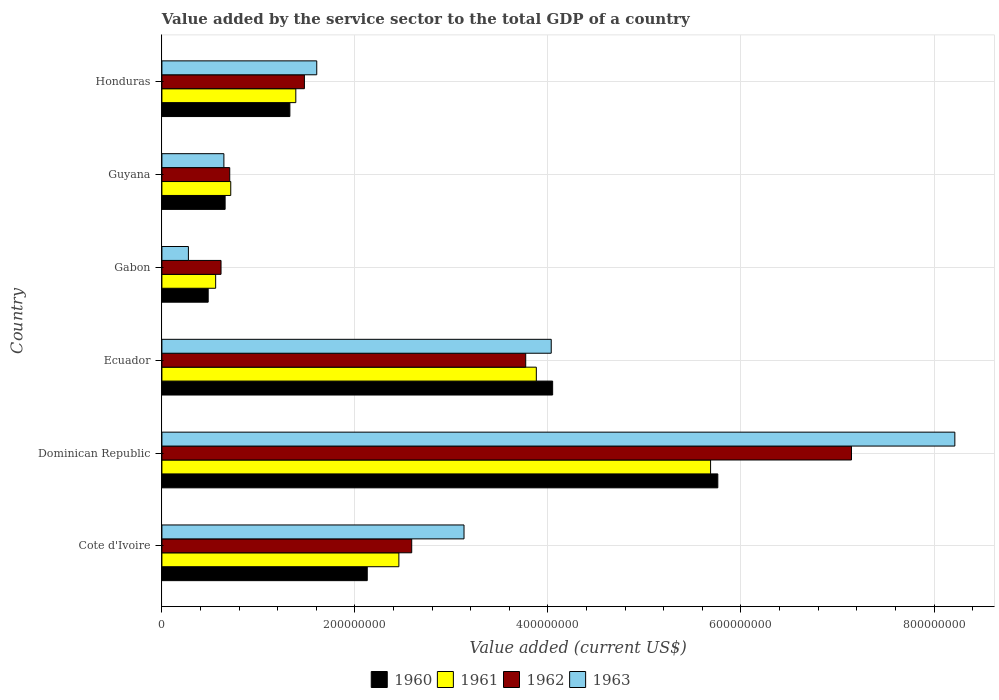How many different coloured bars are there?
Provide a succinct answer. 4. How many bars are there on the 2nd tick from the top?
Keep it short and to the point. 4. How many bars are there on the 2nd tick from the bottom?
Your response must be concise. 4. What is the label of the 3rd group of bars from the top?
Your answer should be compact. Gabon. What is the value added by the service sector to the total GDP in 1961 in Guyana?
Give a very brief answer. 7.13e+07. Across all countries, what is the maximum value added by the service sector to the total GDP in 1962?
Ensure brevity in your answer.  7.14e+08. Across all countries, what is the minimum value added by the service sector to the total GDP in 1961?
Provide a succinct answer. 5.57e+07. In which country was the value added by the service sector to the total GDP in 1962 maximum?
Provide a short and direct response. Dominican Republic. In which country was the value added by the service sector to the total GDP in 1961 minimum?
Your answer should be compact. Gabon. What is the total value added by the service sector to the total GDP in 1963 in the graph?
Your answer should be very brief. 1.79e+09. What is the difference between the value added by the service sector to the total GDP in 1960 in Ecuador and that in Guyana?
Your answer should be very brief. 3.39e+08. What is the difference between the value added by the service sector to the total GDP in 1963 in Guyana and the value added by the service sector to the total GDP in 1961 in Gabon?
Offer a terse response. 8.53e+06. What is the average value added by the service sector to the total GDP in 1960 per country?
Your answer should be very brief. 2.40e+08. What is the difference between the value added by the service sector to the total GDP in 1961 and value added by the service sector to the total GDP in 1963 in Honduras?
Make the answer very short. -2.17e+07. In how many countries, is the value added by the service sector to the total GDP in 1961 greater than 360000000 US$?
Offer a very short reply. 2. What is the ratio of the value added by the service sector to the total GDP in 1961 in Dominican Republic to that in Ecuador?
Give a very brief answer. 1.47. Is the difference between the value added by the service sector to the total GDP in 1961 in Cote d'Ivoire and Dominican Republic greater than the difference between the value added by the service sector to the total GDP in 1963 in Cote d'Ivoire and Dominican Republic?
Your answer should be very brief. Yes. What is the difference between the highest and the second highest value added by the service sector to the total GDP in 1963?
Provide a short and direct response. 4.18e+08. What is the difference between the highest and the lowest value added by the service sector to the total GDP in 1962?
Your answer should be compact. 6.53e+08. In how many countries, is the value added by the service sector to the total GDP in 1961 greater than the average value added by the service sector to the total GDP in 1961 taken over all countries?
Ensure brevity in your answer.  3. What does the 2nd bar from the bottom in Cote d'Ivoire represents?
Give a very brief answer. 1961. Is it the case that in every country, the sum of the value added by the service sector to the total GDP in 1962 and value added by the service sector to the total GDP in 1963 is greater than the value added by the service sector to the total GDP in 1961?
Your answer should be very brief. Yes. How many bars are there?
Offer a terse response. 24. Are all the bars in the graph horizontal?
Give a very brief answer. Yes. Are the values on the major ticks of X-axis written in scientific E-notation?
Keep it short and to the point. No. Does the graph contain any zero values?
Give a very brief answer. No. Does the graph contain grids?
Give a very brief answer. Yes. What is the title of the graph?
Keep it short and to the point. Value added by the service sector to the total GDP of a country. Does "1965" appear as one of the legend labels in the graph?
Make the answer very short. No. What is the label or title of the X-axis?
Provide a succinct answer. Value added (current US$). What is the label or title of the Y-axis?
Provide a short and direct response. Country. What is the Value added (current US$) in 1960 in Cote d'Ivoire?
Your answer should be very brief. 2.13e+08. What is the Value added (current US$) of 1961 in Cote d'Ivoire?
Provide a succinct answer. 2.46e+08. What is the Value added (current US$) of 1962 in Cote d'Ivoire?
Your answer should be very brief. 2.59e+08. What is the Value added (current US$) in 1963 in Cote d'Ivoire?
Provide a short and direct response. 3.13e+08. What is the Value added (current US$) of 1960 in Dominican Republic?
Offer a terse response. 5.76e+08. What is the Value added (current US$) in 1961 in Dominican Republic?
Provide a short and direct response. 5.68e+08. What is the Value added (current US$) in 1962 in Dominican Republic?
Your answer should be compact. 7.14e+08. What is the Value added (current US$) of 1963 in Dominican Republic?
Your response must be concise. 8.22e+08. What is the Value added (current US$) of 1960 in Ecuador?
Give a very brief answer. 4.05e+08. What is the Value added (current US$) in 1961 in Ecuador?
Your response must be concise. 3.88e+08. What is the Value added (current US$) in 1962 in Ecuador?
Give a very brief answer. 3.77e+08. What is the Value added (current US$) of 1963 in Ecuador?
Give a very brief answer. 4.03e+08. What is the Value added (current US$) in 1960 in Gabon?
Your answer should be compact. 4.80e+07. What is the Value added (current US$) in 1961 in Gabon?
Give a very brief answer. 5.57e+07. What is the Value added (current US$) of 1962 in Gabon?
Give a very brief answer. 6.13e+07. What is the Value added (current US$) of 1963 in Gabon?
Ensure brevity in your answer.  2.75e+07. What is the Value added (current US$) in 1960 in Guyana?
Provide a short and direct response. 6.55e+07. What is the Value added (current US$) in 1961 in Guyana?
Offer a terse response. 7.13e+07. What is the Value added (current US$) of 1962 in Guyana?
Offer a terse response. 7.03e+07. What is the Value added (current US$) of 1963 in Guyana?
Provide a short and direct response. 6.42e+07. What is the Value added (current US$) in 1960 in Honduras?
Provide a short and direct response. 1.33e+08. What is the Value added (current US$) in 1961 in Honduras?
Your answer should be very brief. 1.39e+08. What is the Value added (current US$) of 1962 in Honduras?
Offer a very short reply. 1.48e+08. What is the Value added (current US$) in 1963 in Honduras?
Offer a terse response. 1.60e+08. Across all countries, what is the maximum Value added (current US$) in 1960?
Make the answer very short. 5.76e+08. Across all countries, what is the maximum Value added (current US$) of 1961?
Your answer should be compact. 5.68e+08. Across all countries, what is the maximum Value added (current US$) of 1962?
Provide a short and direct response. 7.14e+08. Across all countries, what is the maximum Value added (current US$) in 1963?
Your answer should be compact. 8.22e+08. Across all countries, what is the minimum Value added (current US$) of 1960?
Keep it short and to the point. 4.80e+07. Across all countries, what is the minimum Value added (current US$) in 1961?
Your response must be concise. 5.57e+07. Across all countries, what is the minimum Value added (current US$) in 1962?
Offer a terse response. 6.13e+07. Across all countries, what is the minimum Value added (current US$) in 1963?
Make the answer very short. 2.75e+07. What is the total Value added (current US$) of 1960 in the graph?
Make the answer very short. 1.44e+09. What is the total Value added (current US$) in 1961 in the graph?
Give a very brief answer. 1.47e+09. What is the total Value added (current US$) in 1962 in the graph?
Keep it short and to the point. 1.63e+09. What is the total Value added (current US$) of 1963 in the graph?
Offer a terse response. 1.79e+09. What is the difference between the Value added (current US$) of 1960 in Cote d'Ivoire and that in Dominican Republic?
Your response must be concise. -3.63e+08. What is the difference between the Value added (current US$) in 1961 in Cote d'Ivoire and that in Dominican Republic?
Your answer should be very brief. -3.23e+08. What is the difference between the Value added (current US$) of 1962 in Cote d'Ivoire and that in Dominican Republic?
Give a very brief answer. -4.56e+08. What is the difference between the Value added (current US$) of 1963 in Cote d'Ivoire and that in Dominican Republic?
Give a very brief answer. -5.09e+08. What is the difference between the Value added (current US$) in 1960 in Cote d'Ivoire and that in Ecuador?
Make the answer very short. -1.92e+08. What is the difference between the Value added (current US$) in 1961 in Cote d'Ivoire and that in Ecuador?
Provide a succinct answer. -1.42e+08. What is the difference between the Value added (current US$) in 1962 in Cote d'Ivoire and that in Ecuador?
Your answer should be very brief. -1.18e+08. What is the difference between the Value added (current US$) of 1963 in Cote d'Ivoire and that in Ecuador?
Your answer should be compact. -9.04e+07. What is the difference between the Value added (current US$) of 1960 in Cote d'Ivoire and that in Gabon?
Offer a very short reply. 1.65e+08. What is the difference between the Value added (current US$) in 1961 in Cote d'Ivoire and that in Gabon?
Offer a terse response. 1.90e+08. What is the difference between the Value added (current US$) in 1962 in Cote d'Ivoire and that in Gabon?
Offer a terse response. 1.98e+08. What is the difference between the Value added (current US$) of 1963 in Cote d'Ivoire and that in Gabon?
Your answer should be compact. 2.86e+08. What is the difference between the Value added (current US$) of 1960 in Cote d'Ivoire and that in Guyana?
Provide a short and direct response. 1.47e+08. What is the difference between the Value added (current US$) in 1961 in Cote d'Ivoire and that in Guyana?
Your answer should be very brief. 1.74e+08. What is the difference between the Value added (current US$) of 1962 in Cote d'Ivoire and that in Guyana?
Your answer should be very brief. 1.89e+08. What is the difference between the Value added (current US$) in 1963 in Cote d'Ivoire and that in Guyana?
Keep it short and to the point. 2.49e+08. What is the difference between the Value added (current US$) of 1960 in Cote d'Ivoire and that in Honduras?
Provide a short and direct response. 8.02e+07. What is the difference between the Value added (current US$) in 1961 in Cote d'Ivoire and that in Honduras?
Keep it short and to the point. 1.07e+08. What is the difference between the Value added (current US$) in 1962 in Cote d'Ivoire and that in Honduras?
Keep it short and to the point. 1.11e+08. What is the difference between the Value added (current US$) of 1963 in Cote d'Ivoire and that in Honduras?
Keep it short and to the point. 1.53e+08. What is the difference between the Value added (current US$) of 1960 in Dominican Republic and that in Ecuador?
Provide a short and direct response. 1.71e+08. What is the difference between the Value added (current US$) of 1961 in Dominican Republic and that in Ecuador?
Give a very brief answer. 1.81e+08. What is the difference between the Value added (current US$) of 1962 in Dominican Republic and that in Ecuador?
Make the answer very short. 3.38e+08. What is the difference between the Value added (current US$) in 1963 in Dominican Republic and that in Ecuador?
Make the answer very short. 4.18e+08. What is the difference between the Value added (current US$) of 1960 in Dominican Republic and that in Gabon?
Offer a very short reply. 5.28e+08. What is the difference between the Value added (current US$) of 1961 in Dominican Republic and that in Gabon?
Provide a short and direct response. 5.13e+08. What is the difference between the Value added (current US$) of 1962 in Dominican Republic and that in Gabon?
Ensure brevity in your answer.  6.53e+08. What is the difference between the Value added (current US$) in 1963 in Dominican Republic and that in Gabon?
Offer a very short reply. 7.94e+08. What is the difference between the Value added (current US$) in 1960 in Dominican Republic and that in Guyana?
Offer a very short reply. 5.10e+08. What is the difference between the Value added (current US$) of 1961 in Dominican Republic and that in Guyana?
Offer a very short reply. 4.97e+08. What is the difference between the Value added (current US$) in 1962 in Dominican Republic and that in Guyana?
Provide a short and direct response. 6.44e+08. What is the difference between the Value added (current US$) in 1963 in Dominican Republic and that in Guyana?
Give a very brief answer. 7.57e+08. What is the difference between the Value added (current US$) of 1960 in Dominican Republic and that in Honduras?
Offer a terse response. 4.43e+08. What is the difference between the Value added (current US$) of 1961 in Dominican Republic and that in Honduras?
Your response must be concise. 4.30e+08. What is the difference between the Value added (current US$) in 1962 in Dominican Republic and that in Honduras?
Give a very brief answer. 5.67e+08. What is the difference between the Value added (current US$) in 1963 in Dominican Republic and that in Honduras?
Offer a terse response. 6.61e+08. What is the difference between the Value added (current US$) of 1960 in Ecuador and that in Gabon?
Your answer should be compact. 3.57e+08. What is the difference between the Value added (current US$) in 1961 in Ecuador and that in Gabon?
Your response must be concise. 3.32e+08. What is the difference between the Value added (current US$) of 1962 in Ecuador and that in Gabon?
Ensure brevity in your answer.  3.16e+08. What is the difference between the Value added (current US$) in 1963 in Ecuador and that in Gabon?
Offer a very short reply. 3.76e+08. What is the difference between the Value added (current US$) of 1960 in Ecuador and that in Guyana?
Ensure brevity in your answer.  3.39e+08. What is the difference between the Value added (current US$) of 1961 in Ecuador and that in Guyana?
Offer a very short reply. 3.17e+08. What is the difference between the Value added (current US$) of 1962 in Ecuador and that in Guyana?
Make the answer very short. 3.07e+08. What is the difference between the Value added (current US$) in 1963 in Ecuador and that in Guyana?
Offer a terse response. 3.39e+08. What is the difference between the Value added (current US$) of 1960 in Ecuador and that in Honduras?
Give a very brief answer. 2.72e+08. What is the difference between the Value added (current US$) in 1961 in Ecuador and that in Honduras?
Provide a succinct answer. 2.49e+08. What is the difference between the Value added (current US$) in 1962 in Ecuador and that in Honduras?
Your answer should be compact. 2.29e+08. What is the difference between the Value added (current US$) in 1963 in Ecuador and that in Honduras?
Ensure brevity in your answer.  2.43e+08. What is the difference between the Value added (current US$) of 1960 in Gabon and that in Guyana?
Offer a very short reply. -1.76e+07. What is the difference between the Value added (current US$) of 1961 in Gabon and that in Guyana?
Make the answer very short. -1.56e+07. What is the difference between the Value added (current US$) in 1962 in Gabon and that in Guyana?
Provide a short and direct response. -9.03e+06. What is the difference between the Value added (current US$) in 1963 in Gabon and that in Guyana?
Give a very brief answer. -3.68e+07. What is the difference between the Value added (current US$) in 1960 in Gabon and that in Honduras?
Your response must be concise. -8.46e+07. What is the difference between the Value added (current US$) of 1961 in Gabon and that in Honduras?
Make the answer very short. -8.31e+07. What is the difference between the Value added (current US$) in 1962 in Gabon and that in Honduras?
Offer a terse response. -8.64e+07. What is the difference between the Value added (current US$) of 1963 in Gabon and that in Honduras?
Provide a short and direct response. -1.33e+08. What is the difference between the Value added (current US$) of 1960 in Guyana and that in Honduras?
Ensure brevity in your answer.  -6.71e+07. What is the difference between the Value added (current US$) in 1961 in Guyana and that in Honduras?
Ensure brevity in your answer.  -6.74e+07. What is the difference between the Value added (current US$) of 1962 in Guyana and that in Honduras?
Offer a terse response. -7.74e+07. What is the difference between the Value added (current US$) in 1963 in Guyana and that in Honduras?
Provide a succinct answer. -9.62e+07. What is the difference between the Value added (current US$) of 1960 in Cote d'Ivoire and the Value added (current US$) of 1961 in Dominican Republic?
Provide a succinct answer. -3.56e+08. What is the difference between the Value added (current US$) of 1960 in Cote d'Ivoire and the Value added (current US$) of 1962 in Dominican Republic?
Provide a succinct answer. -5.02e+08. What is the difference between the Value added (current US$) in 1960 in Cote d'Ivoire and the Value added (current US$) in 1963 in Dominican Republic?
Make the answer very short. -6.09e+08. What is the difference between the Value added (current US$) in 1961 in Cote d'Ivoire and the Value added (current US$) in 1962 in Dominican Republic?
Provide a short and direct response. -4.69e+08. What is the difference between the Value added (current US$) in 1961 in Cote d'Ivoire and the Value added (current US$) in 1963 in Dominican Republic?
Offer a terse response. -5.76e+08. What is the difference between the Value added (current US$) of 1962 in Cote d'Ivoire and the Value added (current US$) of 1963 in Dominican Republic?
Offer a very short reply. -5.63e+08. What is the difference between the Value added (current US$) in 1960 in Cote d'Ivoire and the Value added (current US$) in 1961 in Ecuador?
Offer a very short reply. -1.75e+08. What is the difference between the Value added (current US$) of 1960 in Cote d'Ivoire and the Value added (current US$) of 1962 in Ecuador?
Offer a terse response. -1.64e+08. What is the difference between the Value added (current US$) in 1960 in Cote d'Ivoire and the Value added (current US$) in 1963 in Ecuador?
Your answer should be very brief. -1.91e+08. What is the difference between the Value added (current US$) in 1961 in Cote d'Ivoire and the Value added (current US$) in 1962 in Ecuador?
Keep it short and to the point. -1.31e+08. What is the difference between the Value added (current US$) of 1961 in Cote d'Ivoire and the Value added (current US$) of 1963 in Ecuador?
Give a very brief answer. -1.58e+08. What is the difference between the Value added (current US$) of 1962 in Cote d'Ivoire and the Value added (current US$) of 1963 in Ecuador?
Make the answer very short. -1.45e+08. What is the difference between the Value added (current US$) of 1960 in Cote d'Ivoire and the Value added (current US$) of 1961 in Gabon?
Provide a succinct answer. 1.57e+08. What is the difference between the Value added (current US$) in 1960 in Cote d'Ivoire and the Value added (current US$) in 1962 in Gabon?
Provide a short and direct response. 1.52e+08. What is the difference between the Value added (current US$) in 1960 in Cote d'Ivoire and the Value added (current US$) in 1963 in Gabon?
Your answer should be very brief. 1.85e+08. What is the difference between the Value added (current US$) in 1961 in Cote d'Ivoire and the Value added (current US$) in 1962 in Gabon?
Your answer should be compact. 1.84e+08. What is the difference between the Value added (current US$) in 1961 in Cote d'Ivoire and the Value added (current US$) in 1963 in Gabon?
Your answer should be very brief. 2.18e+08. What is the difference between the Value added (current US$) in 1962 in Cote d'Ivoire and the Value added (current US$) in 1963 in Gabon?
Your answer should be very brief. 2.31e+08. What is the difference between the Value added (current US$) of 1960 in Cote d'Ivoire and the Value added (current US$) of 1961 in Guyana?
Your answer should be compact. 1.41e+08. What is the difference between the Value added (current US$) of 1960 in Cote d'Ivoire and the Value added (current US$) of 1962 in Guyana?
Provide a succinct answer. 1.42e+08. What is the difference between the Value added (current US$) in 1960 in Cote d'Ivoire and the Value added (current US$) in 1963 in Guyana?
Offer a terse response. 1.49e+08. What is the difference between the Value added (current US$) in 1961 in Cote d'Ivoire and the Value added (current US$) in 1962 in Guyana?
Offer a terse response. 1.75e+08. What is the difference between the Value added (current US$) in 1961 in Cote d'Ivoire and the Value added (current US$) in 1963 in Guyana?
Give a very brief answer. 1.81e+08. What is the difference between the Value added (current US$) of 1962 in Cote d'Ivoire and the Value added (current US$) of 1963 in Guyana?
Your response must be concise. 1.95e+08. What is the difference between the Value added (current US$) in 1960 in Cote d'Ivoire and the Value added (current US$) in 1961 in Honduras?
Give a very brief answer. 7.40e+07. What is the difference between the Value added (current US$) of 1960 in Cote d'Ivoire and the Value added (current US$) of 1962 in Honduras?
Provide a succinct answer. 6.51e+07. What is the difference between the Value added (current US$) in 1960 in Cote d'Ivoire and the Value added (current US$) in 1963 in Honduras?
Make the answer very short. 5.23e+07. What is the difference between the Value added (current US$) of 1961 in Cote d'Ivoire and the Value added (current US$) of 1962 in Honduras?
Your answer should be very brief. 9.79e+07. What is the difference between the Value added (current US$) of 1961 in Cote d'Ivoire and the Value added (current US$) of 1963 in Honduras?
Provide a succinct answer. 8.51e+07. What is the difference between the Value added (current US$) in 1962 in Cote d'Ivoire and the Value added (current US$) in 1963 in Honduras?
Your answer should be very brief. 9.84e+07. What is the difference between the Value added (current US$) in 1960 in Dominican Republic and the Value added (current US$) in 1961 in Ecuador?
Your answer should be very brief. 1.88e+08. What is the difference between the Value added (current US$) of 1960 in Dominican Republic and the Value added (current US$) of 1962 in Ecuador?
Ensure brevity in your answer.  1.99e+08. What is the difference between the Value added (current US$) of 1960 in Dominican Republic and the Value added (current US$) of 1963 in Ecuador?
Offer a terse response. 1.73e+08. What is the difference between the Value added (current US$) in 1961 in Dominican Republic and the Value added (current US$) in 1962 in Ecuador?
Your answer should be very brief. 1.92e+08. What is the difference between the Value added (current US$) of 1961 in Dominican Republic and the Value added (current US$) of 1963 in Ecuador?
Make the answer very short. 1.65e+08. What is the difference between the Value added (current US$) of 1962 in Dominican Republic and the Value added (current US$) of 1963 in Ecuador?
Keep it short and to the point. 3.11e+08. What is the difference between the Value added (current US$) in 1960 in Dominican Republic and the Value added (current US$) in 1961 in Gabon?
Offer a very short reply. 5.20e+08. What is the difference between the Value added (current US$) in 1960 in Dominican Republic and the Value added (current US$) in 1962 in Gabon?
Ensure brevity in your answer.  5.15e+08. What is the difference between the Value added (current US$) in 1960 in Dominican Republic and the Value added (current US$) in 1963 in Gabon?
Your answer should be very brief. 5.49e+08. What is the difference between the Value added (current US$) of 1961 in Dominican Republic and the Value added (current US$) of 1962 in Gabon?
Provide a short and direct response. 5.07e+08. What is the difference between the Value added (current US$) of 1961 in Dominican Republic and the Value added (current US$) of 1963 in Gabon?
Offer a terse response. 5.41e+08. What is the difference between the Value added (current US$) of 1962 in Dominican Republic and the Value added (current US$) of 1963 in Gabon?
Keep it short and to the point. 6.87e+08. What is the difference between the Value added (current US$) of 1960 in Dominican Republic and the Value added (current US$) of 1961 in Guyana?
Provide a succinct answer. 5.05e+08. What is the difference between the Value added (current US$) in 1960 in Dominican Republic and the Value added (current US$) in 1962 in Guyana?
Give a very brief answer. 5.06e+08. What is the difference between the Value added (current US$) in 1960 in Dominican Republic and the Value added (current US$) in 1963 in Guyana?
Your answer should be very brief. 5.12e+08. What is the difference between the Value added (current US$) in 1961 in Dominican Republic and the Value added (current US$) in 1962 in Guyana?
Make the answer very short. 4.98e+08. What is the difference between the Value added (current US$) of 1961 in Dominican Republic and the Value added (current US$) of 1963 in Guyana?
Provide a succinct answer. 5.04e+08. What is the difference between the Value added (current US$) in 1962 in Dominican Republic and the Value added (current US$) in 1963 in Guyana?
Your response must be concise. 6.50e+08. What is the difference between the Value added (current US$) in 1960 in Dominican Republic and the Value added (current US$) in 1961 in Honduras?
Provide a short and direct response. 4.37e+08. What is the difference between the Value added (current US$) of 1960 in Dominican Republic and the Value added (current US$) of 1962 in Honduras?
Make the answer very short. 4.28e+08. What is the difference between the Value added (current US$) in 1960 in Dominican Republic and the Value added (current US$) in 1963 in Honduras?
Provide a succinct answer. 4.16e+08. What is the difference between the Value added (current US$) of 1961 in Dominican Republic and the Value added (current US$) of 1962 in Honduras?
Offer a very short reply. 4.21e+08. What is the difference between the Value added (current US$) of 1961 in Dominican Republic and the Value added (current US$) of 1963 in Honduras?
Keep it short and to the point. 4.08e+08. What is the difference between the Value added (current US$) in 1962 in Dominican Republic and the Value added (current US$) in 1963 in Honduras?
Your response must be concise. 5.54e+08. What is the difference between the Value added (current US$) in 1960 in Ecuador and the Value added (current US$) in 1961 in Gabon?
Ensure brevity in your answer.  3.49e+08. What is the difference between the Value added (current US$) of 1960 in Ecuador and the Value added (current US$) of 1962 in Gabon?
Offer a very short reply. 3.44e+08. What is the difference between the Value added (current US$) in 1960 in Ecuador and the Value added (current US$) in 1963 in Gabon?
Ensure brevity in your answer.  3.77e+08. What is the difference between the Value added (current US$) in 1961 in Ecuador and the Value added (current US$) in 1962 in Gabon?
Your response must be concise. 3.27e+08. What is the difference between the Value added (current US$) in 1961 in Ecuador and the Value added (current US$) in 1963 in Gabon?
Keep it short and to the point. 3.60e+08. What is the difference between the Value added (current US$) of 1962 in Ecuador and the Value added (current US$) of 1963 in Gabon?
Offer a terse response. 3.49e+08. What is the difference between the Value added (current US$) in 1960 in Ecuador and the Value added (current US$) in 1961 in Guyana?
Ensure brevity in your answer.  3.34e+08. What is the difference between the Value added (current US$) of 1960 in Ecuador and the Value added (current US$) of 1962 in Guyana?
Ensure brevity in your answer.  3.35e+08. What is the difference between the Value added (current US$) in 1960 in Ecuador and the Value added (current US$) in 1963 in Guyana?
Your response must be concise. 3.41e+08. What is the difference between the Value added (current US$) of 1961 in Ecuador and the Value added (current US$) of 1962 in Guyana?
Ensure brevity in your answer.  3.18e+08. What is the difference between the Value added (current US$) of 1961 in Ecuador and the Value added (current US$) of 1963 in Guyana?
Your answer should be compact. 3.24e+08. What is the difference between the Value added (current US$) in 1962 in Ecuador and the Value added (current US$) in 1963 in Guyana?
Your answer should be very brief. 3.13e+08. What is the difference between the Value added (current US$) of 1960 in Ecuador and the Value added (current US$) of 1961 in Honduras?
Provide a short and direct response. 2.66e+08. What is the difference between the Value added (current US$) in 1960 in Ecuador and the Value added (current US$) in 1962 in Honduras?
Your answer should be very brief. 2.57e+08. What is the difference between the Value added (current US$) of 1960 in Ecuador and the Value added (current US$) of 1963 in Honduras?
Your answer should be very brief. 2.44e+08. What is the difference between the Value added (current US$) in 1961 in Ecuador and the Value added (current US$) in 1962 in Honduras?
Make the answer very short. 2.40e+08. What is the difference between the Value added (current US$) in 1961 in Ecuador and the Value added (current US$) in 1963 in Honduras?
Ensure brevity in your answer.  2.28e+08. What is the difference between the Value added (current US$) in 1962 in Ecuador and the Value added (current US$) in 1963 in Honduras?
Your answer should be compact. 2.17e+08. What is the difference between the Value added (current US$) in 1960 in Gabon and the Value added (current US$) in 1961 in Guyana?
Give a very brief answer. -2.34e+07. What is the difference between the Value added (current US$) in 1960 in Gabon and the Value added (current US$) in 1962 in Guyana?
Your answer should be compact. -2.23e+07. What is the difference between the Value added (current US$) of 1960 in Gabon and the Value added (current US$) of 1963 in Guyana?
Ensure brevity in your answer.  -1.63e+07. What is the difference between the Value added (current US$) of 1961 in Gabon and the Value added (current US$) of 1962 in Guyana?
Your answer should be very brief. -1.46e+07. What is the difference between the Value added (current US$) in 1961 in Gabon and the Value added (current US$) in 1963 in Guyana?
Your answer should be compact. -8.53e+06. What is the difference between the Value added (current US$) of 1962 in Gabon and the Value added (current US$) of 1963 in Guyana?
Offer a terse response. -2.96e+06. What is the difference between the Value added (current US$) in 1960 in Gabon and the Value added (current US$) in 1961 in Honduras?
Make the answer very short. -9.08e+07. What is the difference between the Value added (current US$) in 1960 in Gabon and the Value added (current US$) in 1962 in Honduras?
Make the answer very short. -9.97e+07. What is the difference between the Value added (current US$) of 1960 in Gabon and the Value added (current US$) of 1963 in Honduras?
Offer a very short reply. -1.12e+08. What is the difference between the Value added (current US$) of 1961 in Gabon and the Value added (current US$) of 1962 in Honduras?
Offer a terse response. -9.20e+07. What is the difference between the Value added (current US$) in 1961 in Gabon and the Value added (current US$) in 1963 in Honduras?
Ensure brevity in your answer.  -1.05e+08. What is the difference between the Value added (current US$) in 1962 in Gabon and the Value added (current US$) in 1963 in Honduras?
Your response must be concise. -9.92e+07. What is the difference between the Value added (current US$) in 1960 in Guyana and the Value added (current US$) in 1961 in Honduras?
Give a very brief answer. -7.32e+07. What is the difference between the Value added (current US$) in 1960 in Guyana and the Value added (current US$) in 1962 in Honduras?
Make the answer very short. -8.21e+07. What is the difference between the Value added (current US$) in 1960 in Guyana and the Value added (current US$) in 1963 in Honduras?
Provide a succinct answer. -9.49e+07. What is the difference between the Value added (current US$) in 1961 in Guyana and the Value added (current US$) in 1962 in Honduras?
Ensure brevity in your answer.  -7.63e+07. What is the difference between the Value added (current US$) of 1961 in Guyana and the Value added (current US$) of 1963 in Honduras?
Give a very brief answer. -8.91e+07. What is the difference between the Value added (current US$) in 1962 in Guyana and the Value added (current US$) in 1963 in Honduras?
Offer a very short reply. -9.02e+07. What is the average Value added (current US$) in 1960 per country?
Give a very brief answer. 2.40e+08. What is the average Value added (current US$) of 1961 per country?
Offer a terse response. 2.45e+08. What is the average Value added (current US$) of 1962 per country?
Your response must be concise. 2.72e+08. What is the average Value added (current US$) of 1963 per country?
Your answer should be compact. 2.98e+08. What is the difference between the Value added (current US$) in 1960 and Value added (current US$) in 1961 in Cote d'Ivoire?
Make the answer very short. -3.28e+07. What is the difference between the Value added (current US$) of 1960 and Value added (current US$) of 1962 in Cote d'Ivoire?
Ensure brevity in your answer.  -4.61e+07. What is the difference between the Value added (current US$) of 1960 and Value added (current US$) of 1963 in Cote d'Ivoire?
Offer a very short reply. -1.00e+08. What is the difference between the Value added (current US$) in 1961 and Value added (current US$) in 1962 in Cote d'Ivoire?
Provide a succinct answer. -1.33e+07. What is the difference between the Value added (current US$) in 1961 and Value added (current US$) in 1963 in Cote d'Ivoire?
Your answer should be very brief. -6.75e+07. What is the difference between the Value added (current US$) in 1962 and Value added (current US$) in 1963 in Cote d'Ivoire?
Your answer should be very brief. -5.42e+07. What is the difference between the Value added (current US$) of 1960 and Value added (current US$) of 1961 in Dominican Republic?
Provide a short and direct response. 7.50e+06. What is the difference between the Value added (current US$) in 1960 and Value added (current US$) in 1962 in Dominican Republic?
Keep it short and to the point. -1.39e+08. What is the difference between the Value added (current US$) in 1960 and Value added (current US$) in 1963 in Dominican Republic?
Your response must be concise. -2.46e+08. What is the difference between the Value added (current US$) in 1961 and Value added (current US$) in 1962 in Dominican Republic?
Offer a terse response. -1.46e+08. What is the difference between the Value added (current US$) in 1961 and Value added (current US$) in 1963 in Dominican Republic?
Keep it short and to the point. -2.53e+08. What is the difference between the Value added (current US$) in 1962 and Value added (current US$) in 1963 in Dominican Republic?
Your response must be concise. -1.07e+08. What is the difference between the Value added (current US$) of 1960 and Value added (current US$) of 1961 in Ecuador?
Give a very brief answer. 1.69e+07. What is the difference between the Value added (current US$) of 1960 and Value added (current US$) of 1962 in Ecuador?
Ensure brevity in your answer.  2.79e+07. What is the difference between the Value added (current US$) of 1960 and Value added (current US$) of 1963 in Ecuador?
Your answer should be very brief. 1.47e+06. What is the difference between the Value added (current US$) in 1961 and Value added (current US$) in 1962 in Ecuador?
Your response must be concise. 1.10e+07. What is the difference between the Value added (current US$) of 1961 and Value added (current US$) of 1963 in Ecuador?
Your response must be concise. -1.54e+07. What is the difference between the Value added (current US$) of 1962 and Value added (current US$) of 1963 in Ecuador?
Your answer should be very brief. -2.64e+07. What is the difference between the Value added (current US$) of 1960 and Value added (current US$) of 1961 in Gabon?
Offer a terse response. -7.74e+06. What is the difference between the Value added (current US$) of 1960 and Value added (current US$) of 1962 in Gabon?
Give a very brief answer. -1.33e+07. What is the difference between the Value added (current US$) in 1960 and Value added (current US$) in 1963 in Gabon?
Provide a succinct answer. 2.05e+07. What is the difference between the Value added (current US$) in 1961 and Value added (current US$) in 1962 in Gabon?
Provide a short and direct response. -5.57e+06. What is the difference between the Value added (current US$) of 1961 and Value added (current US$) of 1963 in Gabon?
Offer a very short reply. 2.82e+07. What is the difference between the Value added (current US$) of 1962 and Value added (current US$) of 1963 in Gabon?
Your answer should be very brief. 3.38e+07. What is the difference between the Value added (current US$) in 1960 and Value added (current US$) in 1961 in Guyana?
Offer a terse response. -5.83e+06. What is the difference between the Value added (current US$) of 1960 and Value added (current US$) of 1962 in Guyana?
Keep it short and to the point. -4.78e+06. What is the difference between the Value added (current US$) in 1960 and Value added (current US$) in 1963 in Guyana?
Offer a very short reply. 1.28e+06. What is the difference between the Value added (current US$) in 1961 and Value added (current US$) in 1962 in Guyana?
Ensure brevity in your answer.  1.05e+06. What is the difference between the Value added (current US$) of 1961 and Value added (current US$) of 1963 in Guyana?
Offer a terse response. 7.12e+06. What is the difference between the Value added (current US$) in 1962 and Value added (current US$) in 1963 in Guyana?
Give a very brief answer. 6.07e+06. What is the difference between the Value added (current US$) in 1960 and Value added (current US$) in 1961 in Honduras?
Offer a very short reply. -6.15e+06. What is the difference between the Value added (current US$) in 1960 and Value added (current US$) in 1962 in Honduras?
Offer a terse response. -1.50e+07. What is the difference between the Value added (current US$) of 1960 and Value added (current US$) of 1963 in Honduras?
Your response must be concise. -2.78e+07. What is the difference between the Value added (current US$) of 1961 and Value added (current US$) of 1962 in Honduras?
Provide a succinct answer. -8.90e+06. What is the difference between the Value added (current US$) in 1961 and Value added (current US$) in 1963 in Honduras?
Offer a very short reply. -2.17e+07. What is the difference between the Value added (current US$) of 1962 and Value added (current US$) of 1963 in Honduras?
Give a very brief answer. -1.28e+07. What is the ratio of the Value added (current US$) in 1960 in Cote d'Ivoire to that in Dominican Republic?
Offer a terse response. 0.37. What is the ratio of the Value added (current US$) of 1961 in Cote d'Ivoire to that in Dominican Republic?
Make the answer very short. 0.43. What is the ratio of the Value added (current US$) of 1962 in Cote d'Ivoire to that in Dominican Republic?
Give a very brief answer. 0.36. What is the ratio of the Value added (current US$) in 1963 in Cote d'Ivoire to that in Dominican Republic?
Offer a terse response. 0.38. What is the ratio of the Value added (current US$) in 1960 in Cote d'Ivoire to that in Ecuador?
Provide a succinct answer. 0.53. What is the ratio of the Value added (current US$) in 1961 in Cote d'Ivoire to that in Ecuador?
Keep it short and to the point. 0.63. What is the ratio of the Value added (current US$) in 1962 in Cote d'Ivoire to that in Ecuador?
Your answer should be compact. 0.69. What is the ratio of the Value added (current US$) of 1963 in Cote d'Ivoire to that in Ecuador?
Keep it short and to the point. 0.78. What is the ratio of the Value added (current US$) in 1960 in Cote d'Ivoire to that in Gabon?
Ensure brevity in your answer.  4.44. What is the ratio of the Value added (current US$) of 1961 in Cote d'Ivoire to that in Gabon?
Offer a very short reply. 4.41. What is the ratio of the Value added (current US$) in 1962 in Cote d'Ivoire to that in Gabon?
Provide a short and direct response. 4.23. What is the ratio of the Value added (current US$) in 1963 in Cote d'Ivoire to that in Gabon?
Provide a short and direct response. 11.4. What is the ratio of the Value added (current US$) of 1960 in Cote d'Ivoire to that in Guyana?
Keep it short and to the point. 3.25. What is the ratio of the Value added (current US$) of 1961 in Cote d'Ivoire to that in Guyana?
Provide a short and direct response. 3.44. What is the ratio of the Value added (current US$) in 1962 in Cote d'Ivoire to that in Guyana?
Your response must be concise. 3.68. What is the ratio of the Value added (current US$) in 1963 in Cote d'Ivoire to that in Guyana?
Offer a very short reply. 4.87. What is the ratio of the Value added (current US$) of 1960 in Cote d'Ivoire to that in Honduras?
Offer a terse response. 1.6. What is the ratio of the Value added (current US$) in 1961 in Cote d'Ivoire to that in Honduras?
Provide a short and direct response. 1.77. What is the ratio of the Value added (current US$) of 1962 in Cote d'Ivoire to that in Honduras?
Offer a very short reply. 1.75. What is the ratio of the Value added (current US$) in 1963 in Cote d'Ivoire to that in Honduras?
Make the answer very short. 1.95. What is the ratio of the Value added (current US$) in 1960 in Dominican Republic to that in Ecuador?
Offer a terse response. 1.42. What is the ratio of the Value added (current US$) of 1961 in Dominican Republic to that in Ecuador?
Provide a succinct answer. 1.47. What is the ratio of the Value added (current US$) of 1962 in Dominican Republic to that in Ecuador?
Provide a succinct answer. 1.9. What is the ratio of the Value added (current US$) in 1963 in Dominican Republic to that in Ecuador?
Ensure brevity in your answer.  2.04. What is the ratio of the Value added (current US$) in 1960 in Dominican Republic to that in Gabon?
Your answer should be compact. 12.01. What is the ratio of the Value added (current US$) in 1961 in Dominican Republic to that in Gabon?
Provide a short and direct response. 10.21. What is the ratio of the Value added (current US$) of 1962 in Dominican Republic to that in Gabon?
Offer a terse response. 11.66. What is the ratio of the Value added (current US$) in 1963 in Dominican Republic to that in Gabon?
Offer a very short reply. 29.91. What is the ratio of the Value added (current US$) in 1960 in Dominican Republic to that in Guyana?
Ensure brevity in your answer.  8.79. What is the ratio of the Value added (current US$) in 1961 in Dominican Republic to that in Guyana?
Your answer should be very brief. 7.97. What is the ratio of the Value added (current US$) in 1962 in Dominican Republic to that in Guyana?
Your answer should be compact. 10.16. What is the ratio of the Value added (current US$) in 1963 in Dominican Republic to that in Guyana?
Offer a very short reply. 12.79. What is the ratio of the Value added (current US$) in 1960 in Dominican Republic to that in Honduras?
Provide a succinct answer. 4.34. What is the ratio of the Value added (current US$) of 1961 in Dominican Republic to that in Honduras?
Your answer should be compact. 4.1. What is the ratio of the Value added (current US$) in 1962 in Dominican Republic to that in Honduras?
Provide a succinct answer. 4.84. What is the ratio of the Value added (current US$) in 1963 in Dominican Republic to that in Honduras?
Provide a short and direct response. 5.12. What is the ratio of the Value added (current US$) in 1960 in Ecuador to that in Gabon?
Provide a succinct answer. 8.44. What is the ratio of the Value added (current US$) of 1961 in Ecuador to that in Gabon?
Your answer should be compact. 6.97. What is the ratio of the Value added (current US$) in 1962 in Ecuador to that in Gabon?
Your response must be concise. 6.15. What is the ratio of the Value added (current US$) in 1963 in Ecuador to that in Gabon?
Provide a short and direct response. 14.68. What is the ratio of the Value added (current US$) of 1960 in Ecuador to that in Guyana?
Your answer should be compact. 6.18. What is the ratio of the Value added (current US$) in 1961 in Ecuador to that in Guyana?
Provide a succinct answer. 5.44. What is the ratio of the Value added (current US$) in 1962 in Ecuador to that in Guyana?
Keep it short and to the point. 5.36. What is the ratio of the Value added (current US$) of 1963 in Ecuador to that in Guyana?
Provide a short and direct response. 6.28. What is the ratio of the Value added (current US$) of 1960 in Ecuador to that in Honduras?
Your response must be concise. 3.05. What is the ratio of the Value added (current US$) of 1961 in Ecuador to that in Honduras?
Keep it short and to the point. 2.8. What is the ratio of the Value added (current US$) in 1962 in Ecuador to that in Honduras?
Ensure brevity in your answer.  2.55. What is the ratio of the Value added (current US$) in 1963 in Ecuador to that in Honduras?
Make the answer very short. 2.51. What is the ratio of the Value added (current US$) of 1960 in Gabon to that in Guyana?
Your answer should be very brief. 0.73. What is the ratio of the Value added (current US$) in 1961 in Gabon to that in Guyana?
Your answer should be compact. 0.78. What is the ratio of the Value added (current US$) in 1962 in Gabon to that in Guyana?
Your response must be concise. 0.87. What is the ratio of the Value added (current US$) in 1963 in Gabon to that in Guyana?
Offer a very short reply. 0.43. What is the ratio of the Value added (current US$) in 1960 in Gabon to that in Honduras?
Your answer should be very brief. 0.36. What is the ratio of the Value added (current US$) of 1961 in Gabon to that in Honduras?
Your response must be concise. 0.4. What is the ratio of the Value added (current US$) of 1962 in Gabon to that in Honduras?
Your response must be concise. 0.41. What is the ratio of the Value added (current US$) of 1963 in Gabon to that in Honduras?
Your response must be concise. 0.17. What is the ratio of the Value added (current US$) in 1960 in Guyana to that in Honduras?
Offer a very short reply. 0.49. What is the ratio of the Value added (current US$) in 1961 in Guyana to that in Honduras?
Your answer should be compact. 0.51. What is the ratio of the Value added (current US$) in 1962 in Guyana to that in Honduras?
Provide a short and direct response. 0.48. What is the ratio of the Value added (current US$) in 1963 in Guyana to that in Honduras?
Make the answer very short. 0.4. What is the difference between the highest and the second highest Value added (current US$) of 1960?
Your answer should be compact. 1.71e+08. What is the difference between the highest and the second highest Value added (current US$) of 1961?
Offer a terse response. 1.81e+08. What is the difference between the highest and the second highest Value added (current US$) in 1962?
Provide a succinct answer. 3.38e+08. What is the difference between the highest and the second highest Value added (current US$) of 1963?
Give a very brief answer. 4.18e+08. What is the difference between the highest and the lowest Value added (current US$) in 1960?
Provide a short and direct response. 5.28e+08. What is the difference between the highest and the lowest Value added (current US$) in 1961?
Keep it short and to the point. 5.13e+08. What is the difference between the highest and the lowest Value added (current US$) of 1962?
Your answer should be compact. 6.53e+08. What is the difference between the highest and the lowest Value added (current US$) of 1963?
Your response must be concise. 7.94e+08. 